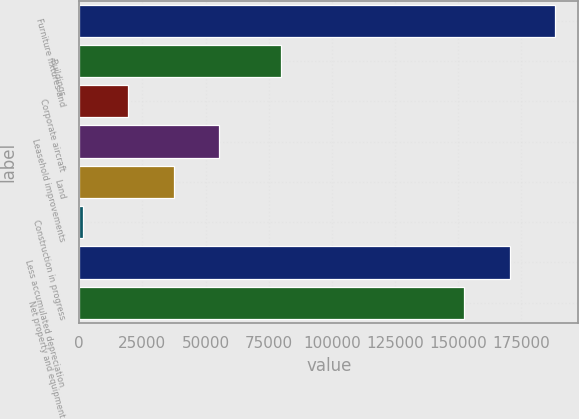Convert chart to OTSL. <chart><loc_0><loc_0><loc_500><loc_500><bar_chart><fcel>Furniture fixtures and<fcel>Buildings<fcel>Corporate aircraft<fcel>Leasehold improvements<fcel>Land<fcel>Construction in progress<fcel>Less accumulated depreciation<fcel>Net property and equipment<nl><fcel>188195<fcel>79981<fcel>19474.1<fcel>55198.3<fcel>37336.2<fcel>1612<fcel>170333<fcel>152471<nl></chart> 